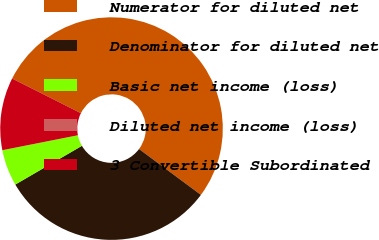<chart> <loc_0><loc_0><loc_500><loc_500><pie_chart><fcel>Numerator for diluted net<fcel>Denominator for diluted net<fcel>Basic net income (loss)<fcel>Diluted net income (loss)<fcel>3 Convertible Subordinated<nl><fcel>52.72%<fcel>31.46%<fcel>5.27%<fcel>0.0%<fcel>10.54%<nl></chart> 